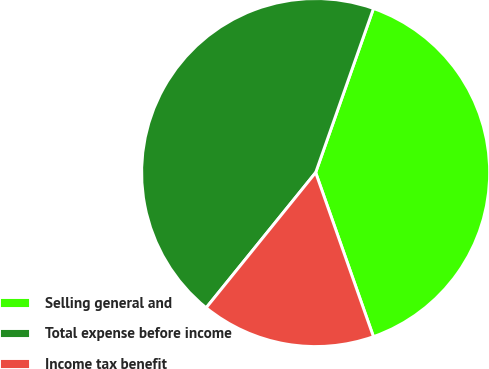Convert chart to OTSL. <chart><loc_0><loc_0><loc_500><loc_500><pie_chart><fcel>Selling general and<fcel>Total expense before income<fcel>Income tax benefit<nl><fcel>39.22%<fcel>44.56%<fcel>16.22%<nl></chart> 